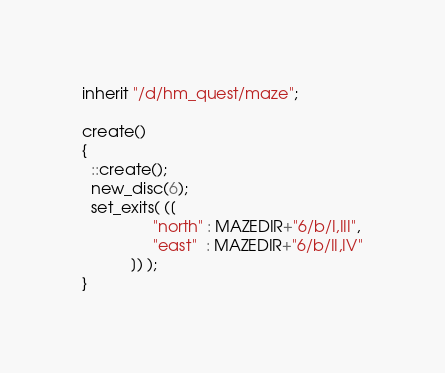Convert code to text. <code><loc_0><loc_0><loc_500><loc_500><_C_>inherit "/d/hm_quest/maze";

create()
{
  ::create();
  new_disc(6);
  set_exits( ([
                "north" : MAZEDIR+"6/b/I,III",
                "east"  : MAZEDIR+"6/b/II,IV"
           ]) );
}
</code> 